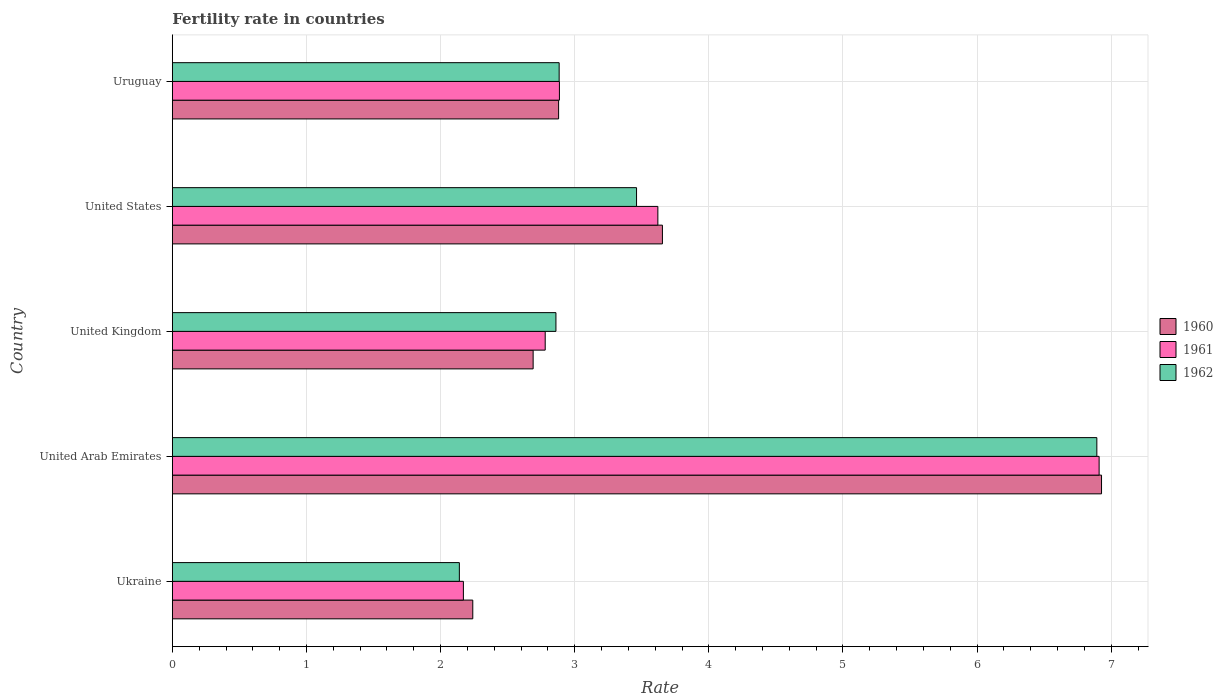How many groups of bars are there?
Give a very brief answer. 5. How many bars are there on the 1st tick from the bottom?
Provide a succinct answer. 3. What is the label of the 1st group of bars from the top?
Make the answer very short. Uruguay. What is the fertility rate in 1961 in Uruguay?
Provide a succinct answer. 2.89. Across all countries, what is the maximum fertility rate in 1962?
Offer a terse response. 6.89. Across all countries, what is the minimum fertility rate in 1961?
Give a very brief answer. 2.17. In which country was the fertility rate in 1961 maximum?
Ensure brevity in your answer.  United Arab Emirates. In which country was the fertility rate in 1960 minimum?
Ensure brevity in your answer.  Ukraine. What is the total fertility rate in 1962 in the graph?
Provide a succinct answer. 18.24. What is the difference between the fertility rate in 1960 in United Arab Emirates and that in United Kingdom?
Your answer should be very brief. 4.24. What is the difference between the fertility rate in 1962 in United Kingdom and the fertility rate in 1961 in United States?
Provide a short and direct response. -0.76. What is the average fertility rate in 1961 per country?
Your answer should be compact. 3.67. What is the difference between the fertility rate in 1960 and fertility rate in 1962 in Ukraine?
Offer a very short reply. 0.1. What is the ratio of the fertility rate in 1961 in Ukraine to that in United Kingdom?
Make the answer very short. 0.78. Is the fertility rate in 1961 in United Kingdom less than that in United States?
Your answer should be very brief. Yes. Is the difference between the fertility rate in 1960 in Ukraine and Uruguay greater than the difference between the fertility rate in 1962 in Ukraine and Uruguay?
Keep it short and to the point. Yes. What is the difference between the highest and the second highest fertility rate in 1960?
Your answer should be compact. 3.27. What is the difference between the highest and the lowest fertility rate in 1960?
Ensure brevity in your answer.  4.69. In how many countries, is the fertility rate in 1962 greater than the average fertility rate in 1962 taken over all countries?
Your answer should be very brief. 1. Is the sum of the fertility rate in 1962 in United Arab Emirates and United States greater than the maximum fertility rate in 1960 across all countries?
Give a very brief answer. Yes. What does the 3rd bar from the top in Ukraine represents?
Make the answer very short. 1960. Is it the case that in every country, the sum of the fertility rate in 1961 and fertility rate in 1960 is greater than the fertility rate in 1962?
Your response must be concise. Yes. How many bars are there?
Offer a terse response. 15. Are all the bars in the graph horizontal?
Provide a succinct answer. Yes. How many countries are there in the graph?
Your answer should be very brief. 5. Are the values on the major ticks of X-axis written in scientific E-notation?
Keep it short and to the point. No. How many legend labels are there?
Provide a succinct answer. 3. How are the legend labels stacked?
Keep it short and to the point. Vertical. What is the title of the graph?
Give a very brief answer. Fertility rate in countries. What is the label or title of the X-axis?
Provide a short and direct response. Rate. What is the label or title of the Y-axis?
Give a very brief answer. Country. What is the Rate in 1960 in Ukraine?
Offer a terse response. 2.24. What is the Rate of 1961 in Ukraine?
Offer a terse response. 2.17. What is the Rate of 1962 in Ukraine?
Give a very brief answer. 2.14. What is the Rate in 1960 in United Arab Emirates?
Keep it short and to the point. 6.93. What is the Rate in 1961 in United Arab Emirates?
Offer a terse response. 6.91. What is the Rate of 1962 in United Arab Emirates?
Offer a terse response. 6.89. What is the Rate in 1960 in United Kingdom?
Make the answer very short. 2.69. What is the Rate in 1961 in United Kingdom?
Offer a very short reply. 2.78. What is the Rate in 1962 in United Kingdom?
Offer a terse response. 2.86. What is the Rate in 1960 in United States?
Offer a terse response. 3.65. What is the Rate of 1961 in United States?
Your answer should be compact. 3.62. What is the Rate of 1962 in United States?
Provide a succinct answer. 3.46. What is the Rate in 1960 in Uruguay?
Provide a succinct answer. 2.88. What is the Rate in 1961 in Uruguay?
Your response must be concise. 2.89. What is the Rate in 1962 in Uruguay?
Give a very brief answer. 2.88. Across all countries, what is the maximum Rate in 1960?
Offer a very short reply. 6.93. Across all countries, what is the maximum Rate of 1961?
Provide a succinct answer. 6.91. Across all countries, what is the maximum Rate of 1962?
Offer a terse response. 6.89. Across all countries, what is the minimum Rate of 1960?
Your answer should be compact. 2.24. Across all countries, what is the minimum Rate of 1961?
Provide a short and direct response. 2.17. Across all countries, what is the minimum Rate of 1962?
Ensure brevity in your answer.  2.14. What is the total Rate in 1960 in the graph?
Your response must be concise. 18.39. What is the total Rate in 1961 in the graph?
Your answer should be compact. 18.37. What is the total Rate of 1962 in the graph?
Ensure brevity in your answer.  18.24. What is the difference between the Rate of 1960 in Ukraine and that in United Arab Emirates?
Your answer should be very brief. -4.69. What is the difference between the Rate of 1961 in Ukraine and that in United Arab Emirates?
Give a very brief answer. -4.74. What is the difference between the Rate in 1962 in Ukraine and that in United Arab Emirates?
Offer a very short reply. -4.75. What is the difference between the Rate of 1960 in Ukraine and that in United Kingdom?
Your answer should be very brief. -0.45. What is the difference between the Rate of 1961 in Ukraine and that in United Kingdom?
Offer a very short reply. -0.61. What is the difference between the Rate in 1962 in Ukraine and that in United Kingdom?
Your response must be concise. -0.72. What is the difference between the Rate in 1960 in Ukraine and that in United States?
Your answer should be very brief. -1.41. What is the difference between the Rate in 1961 in Ukraine and that in United States?
Make the answer very short. -1.45. What is the difference between the Rate in 1962 in Ukraine and that in United States?
Offer a very short reply. -1.32. What is the difference between the Rate of 1960 in Ukraine and that in Uruguay?
Provide a short and direct response. -0.64. What is the difference between the Rate in 1961 in Ukraine and that in Uruguay?
Your response must be concise. -0.72. What is the difference between the Rate of 1962 in Ukraine and that in Uruguay?
Provide a succinct answer. -0.74. What is the difference between the Rate of 1960 in United Arab Emirates and that in United Kingdom?
Your response must be concise. 4.24. What is the difference between the Rate in 1961 in United Arab Emirates and that in United Kingdom?
Ensure brevity in your answer.  4.13. What is the difference between the Rate in 1962 in United Arab Emirates and that in United Kingdom?
Your answer should be very brief. 4.03. What is the difference between the Rate in 1960 in United Arab Emirates and that in United States?
Provide a succinct answer. 3.27. What is the difference between the Rate in 1961 in United Arab Emirates and that in United States?
Ensure brevity in your answer.  3.29. What is the difference between the Rate in 1962 in United Arab Emirates and that in United States?
Provide a short and direct response. 3.43. What is the difference between the Rate in 1960 in United Arab Emirates and that in Uruguay?
Provide a short and direct response. 4.05. What is the difference between the Rate in 1961 in United Arab Emirates and that in Uruguay?
Provide a short and direct response. 4.02. What is the difference between the Rate in 1962 in United Arab Emirates and that in Uruguay?
Offer a terse response. 4.01. What is the difference between the Rate of 1960 in United Kingdom and that in United States?
Give a very brief answer. -0.96. What is the difference between the Rate of 1961 in United Kingdom and that in United States?
Keep it short and to the point. -0.84. What is the difference between the Rate of 1962 in United Kingdom and that in United States?
Your answer should be very brief. -0.6. What is the difference between the Rate of 1960 in United Kingdom and that in Uruguay?
Give a very brief answer. -0.19. What is the difference between the Rate in 1961 in United Kingdom and that in Uruguay?
Make the answer very short. -0.11. What is the difference between the Rate in 1962 in United Kingdom and that in Uruguay?
Offer a very short reply. -0.02. What is the difference between the Rate of 1960 in United States and that in Uruguay?
Ensure brevity in your answer.  0.77. What is the difference between the Rate in 1961 in United States and that in Uruguay?
Offer a very short reply. 0.73. What is the difference between the Rate of 1962 in United States and that in Uruguay?
Provide a succinct answer. 0.58. What is the difference between the Rate in 1960 in Ukraine and the Rate in 1961 in United Arab Emirates?
Provide a short and direct response. -4.67. What is the difference between the Rate of 1960 in Ukraine and the Rate of 1962 in United Arab Emirates?
Make the answer very short. -4.65. What is the difference between the Rate in 1961 in Ukraine and the Rate in 1962 in United Arab Emirates?
Offer a terse response. -4.72. What is the difference between the Rate of 1960 in Ukraine and the Rate of 1961 in United Kingdom?
Offer a very short reply. -0.54. What is the difference between the Rate in 1960 in Ukraine and the Rate in 1962 in United Kingdom?
Make the answer very short. -0.62. What is the difference between the Rate of 1961 in Ukraine and the Rate of 1962 in United Kingdom?
Keep it short and to the point. -0.69. What is the difference between the Rate of 1960 in Ukraine and the Rate of 1961 in United States?
Provide a short and direct response. -1.38. What is the difference between the Rate in 1960 in Ukraine and the Rate in 1962 in United States?
Give a very brief answer. -1.22. What is the difference between the Rate in 1961 in Ukraine and the Rate in 1962 in United States?
Your answer should be compact. -1.29. What is the difference between the Rate of 1960 in Ukraine and the Rate of 1961 in Uruguay?
Keep it short and to the point. -0.65. What is the difference between the Rate in 1960 in Ukraine and the Rate in 1962 in Uruguay?
Give a very brief answer. -0.64. What is the difference between the Rate of 1961 in Ukraine and the Rate of 1962 in Uruguay?
Your answer should be very brief. -0.71. What is the difference between the Rate in 1960 in United Arab Emirates and the Rate in 1961 in United Kingdom?
Provide a succinct answer. 4.15. What is the difference between the Rate in 1960 in United Arab Emirates and the Rate in 1962 in United Kingdom?
Provide a succinct answer. 4.07. What is the difference between the Rate in 1961 in United Arab Emirates and the Rate in 1962 in United Kingdom?
Offer a terse response. 4.05. What is the difference between the Rate in 1960 in United Arab Emirates and the Rate in 1961 in United States?
Your answer should be compact. 3.31. What is the difference between the Rate of 1960 in United Arab Emirates and the Rate of 1962 in United States?
Offer a very short reply. 3.47. What is the difference between the Rate in 1961 in United Arab Emirates and the Rate in 1962 in United States?
Give a very brief answer. 3.45. What is the difference between the Rate in 1960 in United Arab Emirates and the Rate in 1961 in Uruguay?
Your answer should be very brief. 4.04. What is the difference between the Rate of 1960 in United Arab Emirates and the Rate of 1962 in Uruguay?
Your answer should be very brief. 4.04. What is the difference between the Rate in 1961 in United Arab Emirates and the Rate in 1962 in Uruguay?
Your answer should be compact. 4.03. What is the difference between the Rate in 1960 in United Kingdom and the Rate in 1961 in United States?
Provide a succinct answer. -0.93. What is the difference between the Rate in 1960 in United Kingdom and the Rate in 1962 in United States?
Keep it short and to the point. -0.77. What is the difference between the Rate of 1961 in United Kingdom and the Rate of 1962 in United States?
Provide a short and direct response. -0.68. What is the difference between the Rate in 1960 in United Kingdom and the Rate in 1961 in Uruguay?
Ensure brevity in your answer.  -0.2. What is the difference between the Rate in 1960 in United Kingdom and the Rate in 1962 in Uruguay?
Offer a very short reply. -0.19. What is the difference between the Rate in 1961 in United Kingdom and the Rate in 1962 in Uruguay?
Your response must be concise. -0.1. What is the difference between the Rate in 1960 in United States and the Rate in 1961 in Uruguay?
Keep it short and to the point. 0.77. What is the difference between the Rate of 1960 in United States and the Rate of 1962 in Uruguay?
Offer a terse response. 0.77. What is the difference between the Rate in 1961 in United States and the Rate in 1962 in Uruguay?
Offer a terse response. 0.74. What is the average Rate of 1960 per country?
Offer a terse response. 3.68. What is the average Rate in 1961 per country?
Your response must be concise. 3.67. What is the average Rate in 1962 per country?
Your answer should be very brief. 3.65. What is the difference between the Rate of 1960 and Rate of 1961 in Ukraine?
Keep it short and to the point. 0.07. What is the difference between the Rate in 1960 and Rate in 1962 in Ukraine?
Your answer should be compact. 0.1. What is the difference between the Rate of 1960 and Rate of 1961 in United Arab Emirates?
Give a very brief answer. 0.02. What is the difference between the Rate of 1960 and Rate of 1962 in United Arab Emirates?
Your response must be concise. 0.04. What is the difference between the Rate in 1961 and Rate in 1962 in United Arab Emirates?
Ensure brevity in your answer.  0.02. What is the difference between the Rate in 1960 and Rate in 1961 in United Kingdom?
Keep it short and to the point. -0.09. What is the difference between the Rate of 1960 and Rate of 1962 in United Kingdom?
Your answer should be very brief. -0.17. What is the difference between the Rate of 1961 and Rate of 1962 in United Kingdom?
Make the answer very short. -0.08. What is the difference between the Rate of 1960 and Rate of 1961 in United States?
Provide a succinct answer. 0.03. What is the difference between the Rate in 1960 and Rate in 1962 in United States?
Keep it short and to the point. 0.19. What is the difference between the Rate in 1961 and Rate in 1962 in United States?
Provide a short and direct response. 0.16. What is the difference between the Rate in 1960 and Rate in 1961 in Uruguay?
Provide a short and direct response. -0.01. What is the difference between the Rate of 1960 and Rate of 1962 in Uruguay?
Provide a short and direct response. -0. What is the difference between the Rate of 1961 and Rate of 1962 in Uruguay?
Your response must be concise. 0. What is the ratio of the Rate of 1960 in Ukraine to that in United Arab Emirates?
Provide a short and direct response. 0.32. What is the ratio of the Rate in 1961 in Ukraine to that in United Arab Emirates?
Your answer should be compact. 0.31. What is the ratio of the Rate of 1962 in Ukraine to that in United Arab Emirates?
Offer a very short reply. 0.31. What is the ratio of the Rate in 1960 in Ukraine to that in United Kingdom?
Ensure brevity in your answer.  0.83. What is the ratio of the Rate of 1961 in Ukraine to that in United Kingdom?
Offer a terse response. 0.78. What is the ratio of the Rate of 1962 in Ukraine to that in United Kingdom?
Provide a succinct answer. 0.75. What is the ratio of the Rate of 1960 in Ukraine to that in United States?
Ensure brevity in your answer.  0.61. What is the ratio of the Rate in 1961 in Ukraine to that in United States?
Ensure brevity in your answer.  0.6. What is the ratio of the Rate of 1962 in Ukraine to that in United States?
Offer a terse response. 0.62. What is the ratio of the Rate in 1961 in Ukraine to that in Uruguay?
Make the answer very short. 0.75. What is the ratio of the Rate of 1962 in Ukraine to that in Uruguay?
Give a very brief answer. 0.74. What is the ratio of the Rate of 1960 in United Arab Emirates to that in United Kingdom?
Your answer should be very brief. 2.58. What is the ratio of the Rate of 1961 in United Arab Emirates to that in United Kingdom?
Your answer should be very brief. 2.49. What is the ratio of the Rate of 1962 in United Arab Emirates to that in United Kingdom?
Your answer should be very brief. 2.41. What is the ratio of the Rate of 1960 in United Arab Emirates to that in United States?
Ensure brevity in your answer.  1.9. What is the ratio of the Rate of 1961 in United Arab Emirates to that in United States?
Your answer should be very brief. 1.91. What is the ratio of the Rate of 1962 in United Arab Emirates to that in United States?
Ensure brevity in your answer.  1.99. What is the ratio of the Rate of 1960 in United Arab Emirates to that in Uruguay?
Offer a very short reply. 2.41. What is the ratio of the Rate in 1961 in United Arab Emirates to that in Uruguay?
Offer a very short reply. 2.39. What is the ratio of the Rate of 1962 in United Arab Emirates to that in Uruguay?
Offer a very short reply. 2.39. What is the ratio of the Rate in 1960 in United Kingdom to that in United States?
Make the answer very short. 0.74. What is the ratio of the Rate in 1961 in United Kingdom to that in United States?
Ensure brevity in your answer.  0.77. What is the ratio of the Rate in 1962 in United Kingdom to that in United States?
Your response must be concise. 0.83. What is the ratio of the Rate in 1960 in United Kingdom to that in Uruguay?
Make the answer very short. 0.93. What is the ratio of the Rate in 1961 in United Kingdom to that in Uruguay?
Your response must be concise. 0.96. What is the ratio of the Rate in 1962 in United Kingdom to that in Uruguay?
Your response must be concise. 0.99. What is the ratio of the Rate of 1960 in United States to that in Uruguay?
Your answer should be very brief. 1.27. What is the ratio of the Rate in 1961 in United States to that in Uruguay?
Your answer should be very brief. 1.25. What is the ratio of the Rate of 1962 in United States to that in Uruguay?
Keep it short and to the point. 1.2. What is the difference between the highest and the second highest Rate in 1960?
Ensure brevity in your answer.  3.27. What is the difference between the highest and the second highest Rate in 1961?
Provide a succinct answer. 3.29. What is the difference between the highest and the second highest Rate of 1962?
Give a very brief answer. 3.43. What is the difference between the highest and the lowest Rate in 1960?
Your answer should be compact. 4.69. What is the difference between the highest and the lowest Rate in 1961?
Offer a very short reply. 4.74. What is the difference between the highest and the lowest Rate in 1962?
Provide a succinct answer. 4.75. 